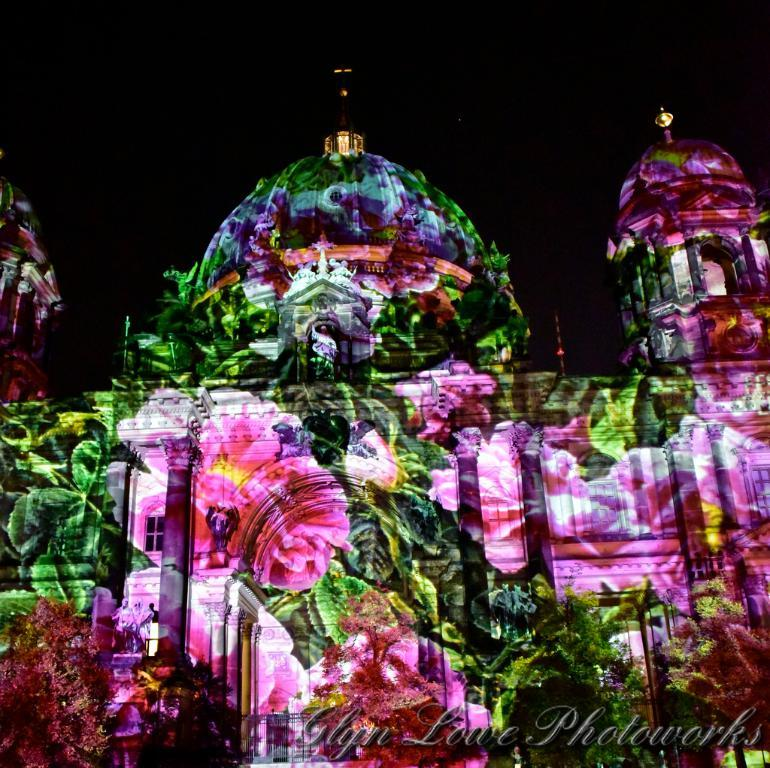What type of natural elements can be seen in the image? There are trees in the image. What man-made structure is featured in the image? There appears to be a light show on a building. Is there any indication of the image's source or ownership? Yes, there is a watermark on the image. What type of animal can be seen in the zoo in the image? There is no zoo present in the image; it features trees and a building with a light show. What type of writing instrument is the governor using in the image? There is no governor or writing instrument present in the image. 